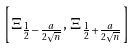<formula> <loc_0><loc_0><loc_500><loc_500>\left [ \Xi _ { \frac { 1 } { 2 } - \frac { a } { 2 \sqrt { n } } } , \, \Xi _ { \frac { 1 } { 2 } + \frac { a } { 2 \sqrt { n } } } \right ]</formula> 